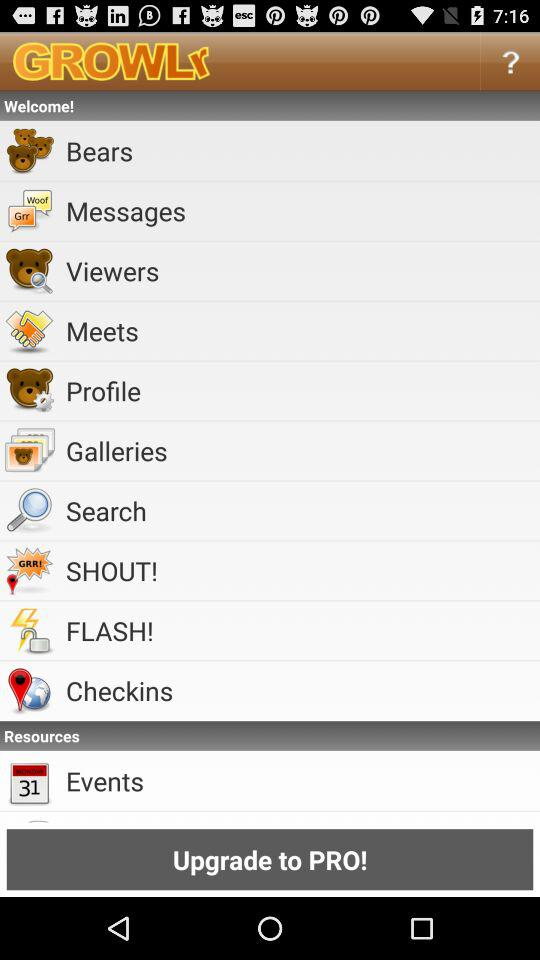What is the name of the application? The name of the application is "GROWLr". 